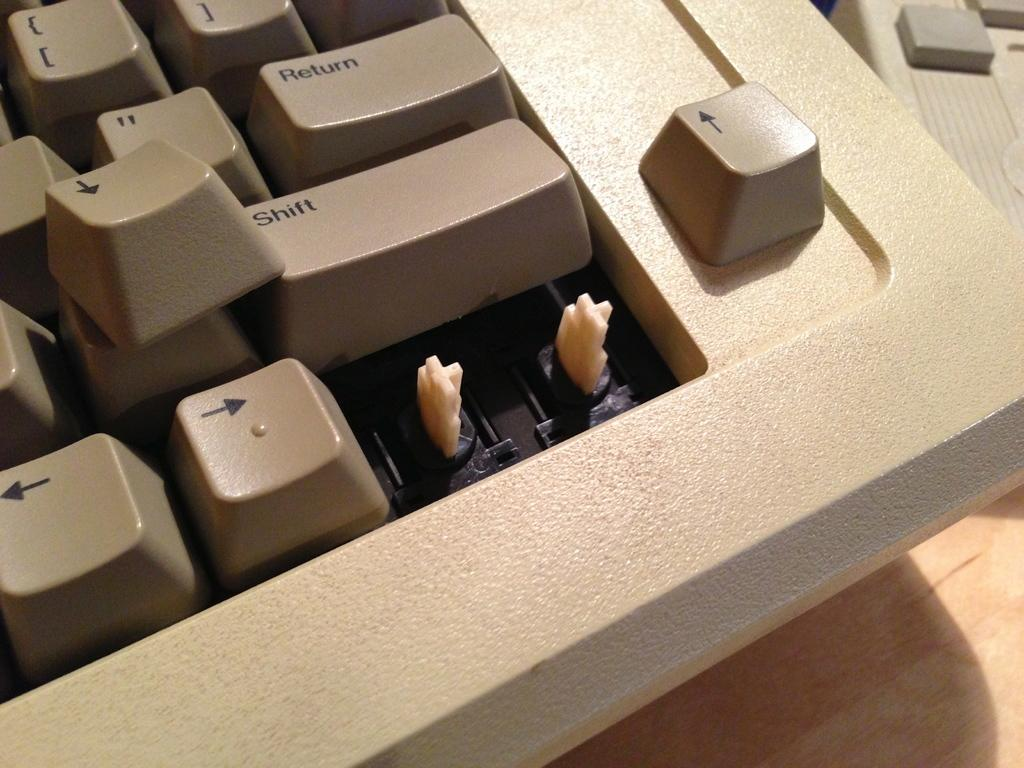<image>
Create a compact narrative representing the image presented. A keyboard with a shift key is missing the bottom two keys. 